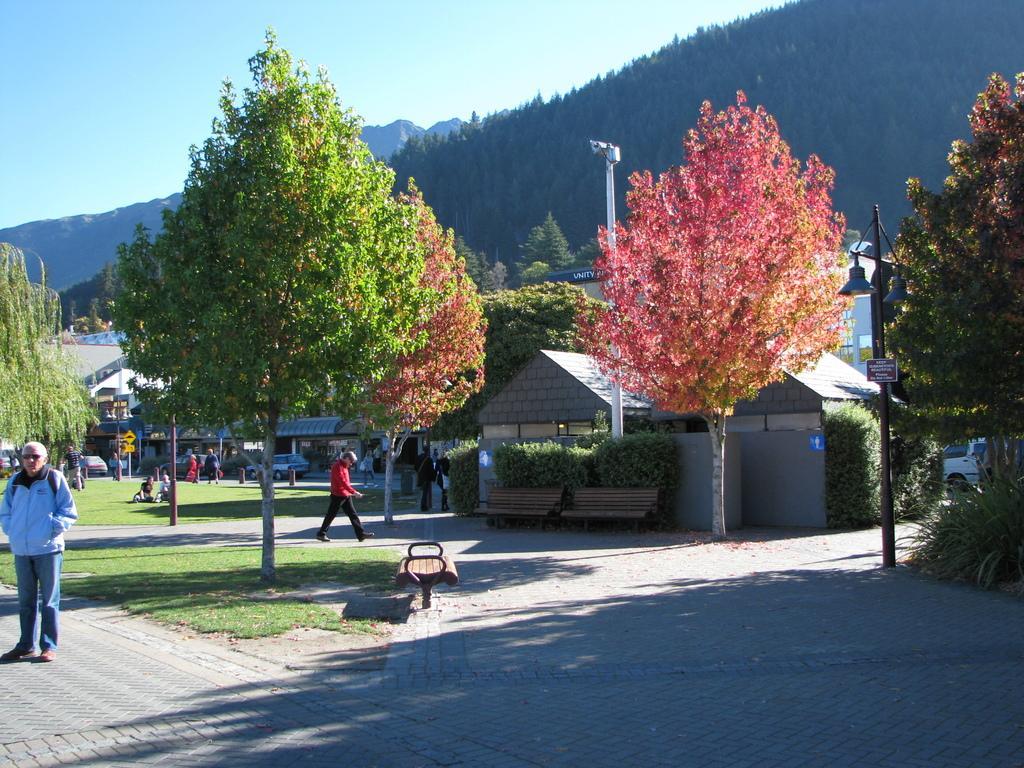Can you describe this image briefly? In this image in front there is a road and people are walking on the road. At the back side there are cars parked on the road and we can see signal boards. In front of the image there are benches, street lights. At the bottom of the image there is grass on the surface. In the background of the image there are trees, buildings, mountains and sky. 